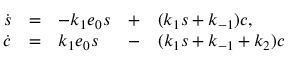<formula> <loc_0><loc_0><loc_500><loc_500>\begin{array} { r c l c l c l } { \dot { s } } & { = } & { - k _ { 1 } e _ { 0 } s } & { + } & { ( k _ { 1 } s + k _ { - 1 } ) c , } \\ { \dot { c } } & { = } & { k _ { 1 } e _ { 0 } s } & { - } & { ( k _ { 1 } s + k _ { - 1 } + k _ { 2 } ) c } \end{array}</formula> 